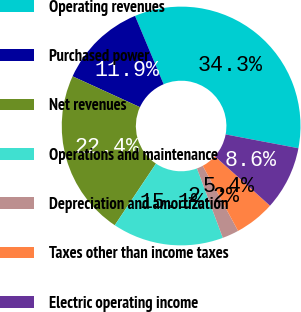<chart> <loc_0><loc_0><loc_500><loc_500><pie_chart><fcel>Operating revenues<fcel>Purchased power<fcel>Net revenues<fcel>Operations and maintenance<fcel>Depreciation and amortization<fcel>Taxes other than income taxes<fcel>Electric operating income<nl><fcel>34.3%<fcel>11.86%<fcel>22.45%<fcel>15.06%<fcel>2.24%<fcel>5.45%<fcel>8.65%<nl></chart> 